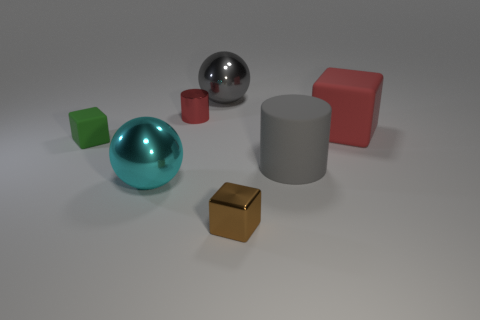Subtract all tiny cubes. How many cubes are left? 1 Add 3 brown metallic things. How many objects exist? 10 Subtract all cylinders. How many objects are left? 5 Subtract all tiny blue metallic cubes. Subtract all gray metallic spheres. How many objects are left? 6 Add 3 large cyan metal balls. How many large cyan metal balls are left? 4 Add 1 big cyan metal spheres. How many big cyan metal spheres exist? 2 Subtract 1 green cubes. How many objects are left? 6 